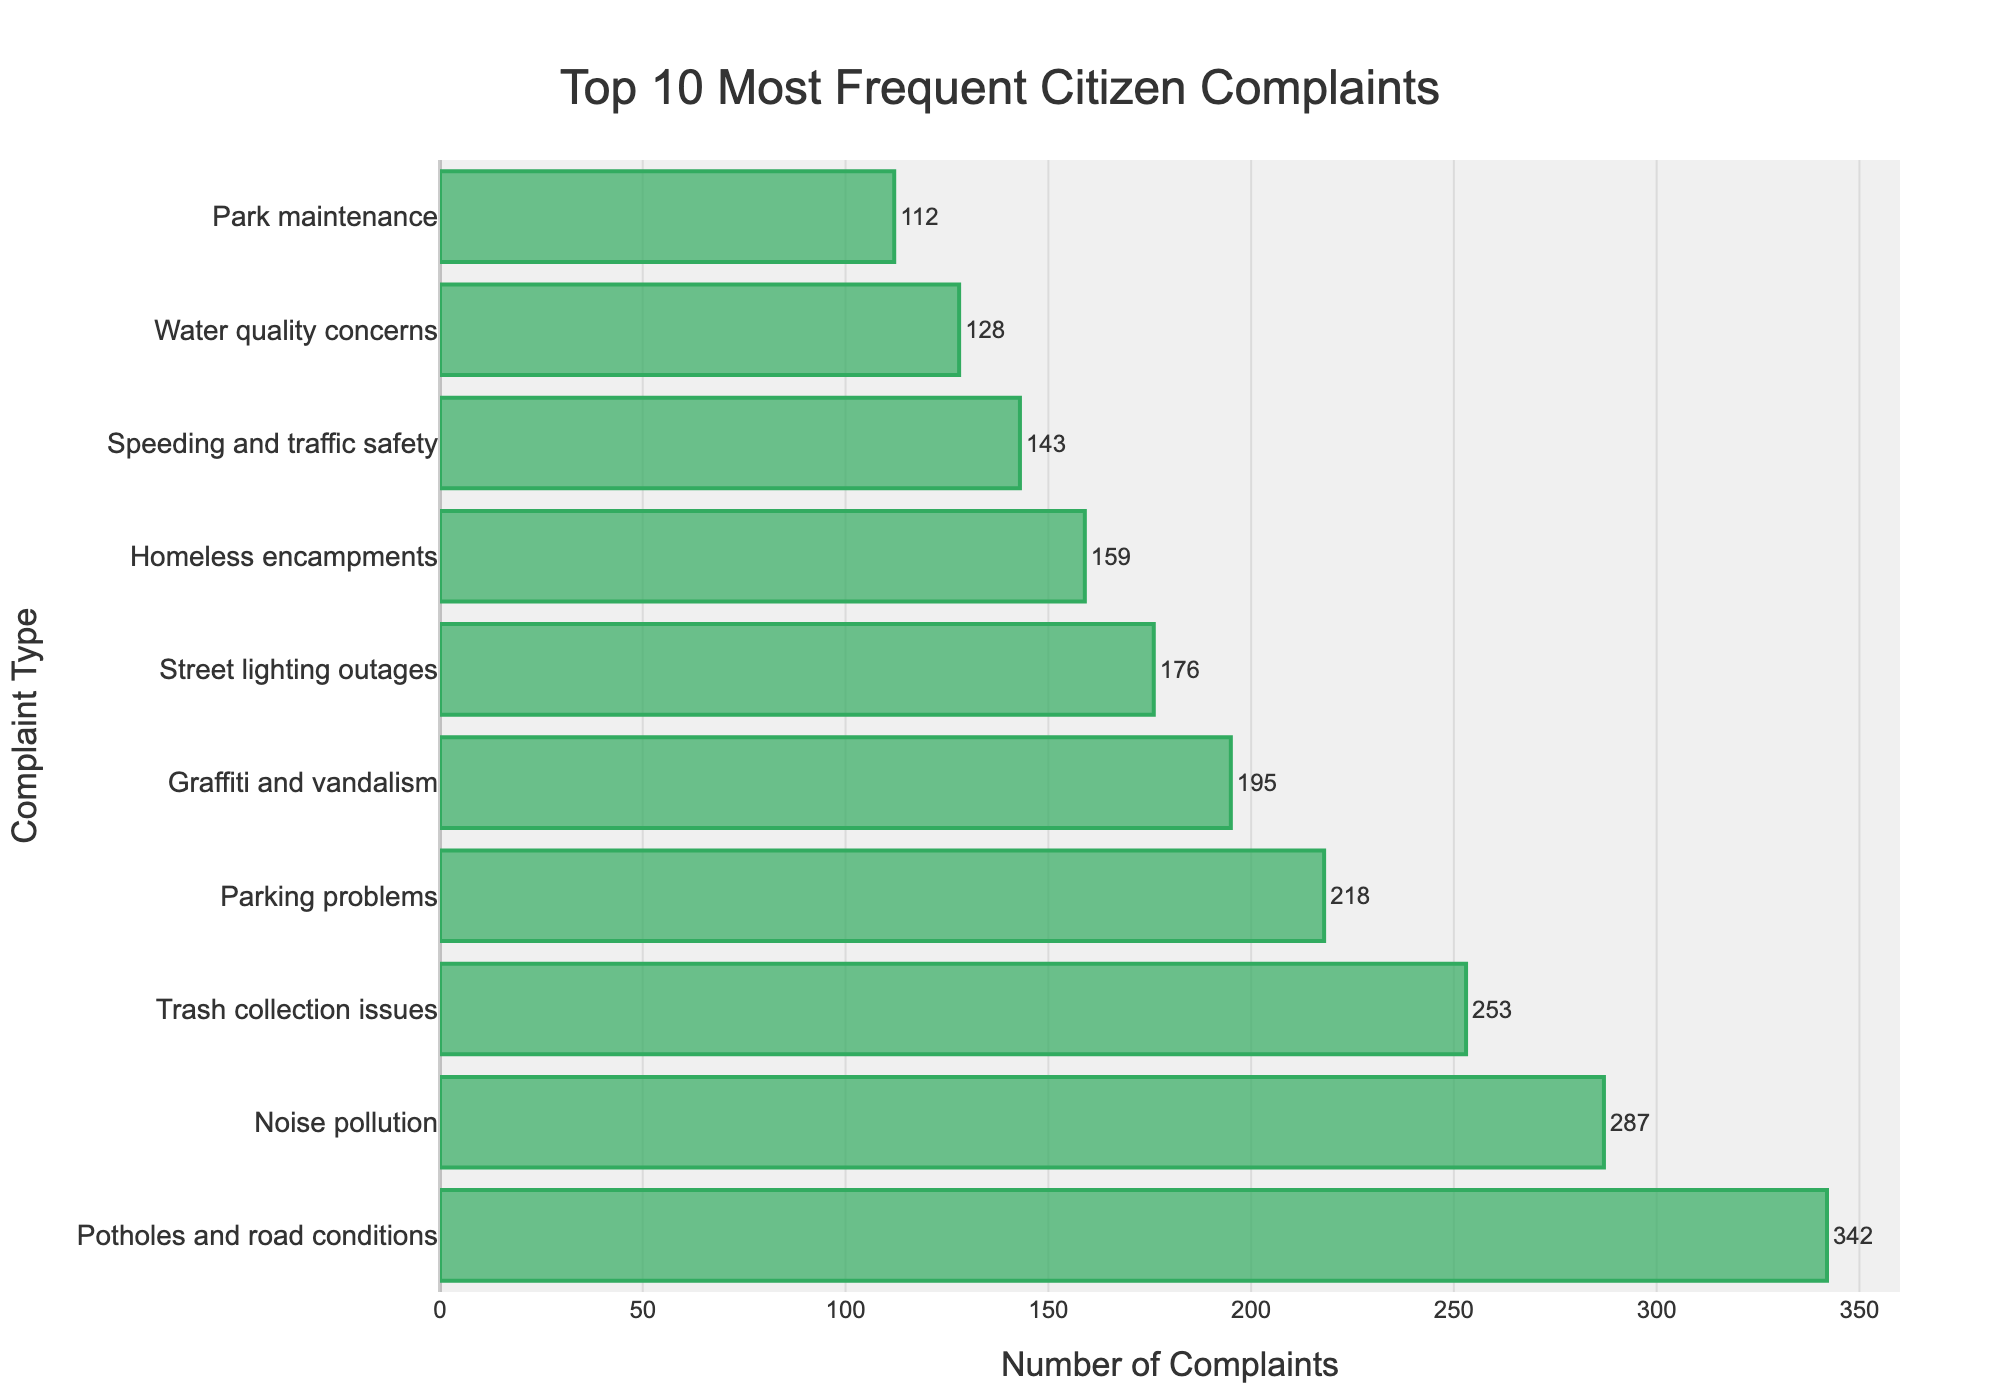Which complaint type has the highest frequency? The complaint type with the highest frequency is identified by the tallest bar. It is "Potholes and road conditions" with a frequency of 342.
Answer: Potholes and road conditions What is the combined frequency of the top three complaint types? The frequencies of the top three complaints ("Potholes and road conditions," "Noise pollution," and "Trash collection issues") are 342, 287, and 253, respectively. Summing these up, 342 + 287 + 253 = 882.
Answer: 882 Which complaint type has a higher frequency: "Graffiti and vandalism" or "Homeless encampments"? Check the lengths of the bars for "Graffiti and vandalism" and "Homeless encampments." "Graffiti and vandalism" has a frequency of 195, while "Homeless encampments" has a frequency of 159. Therefore, "Graffiti and vandalism" has a higher frequency.
Answer: Graffiti and vandalism How many more complaints are there about "Potholes and road conditions" than "Speeding and traffic safety"? Identify the frequencies: "Potholes and road conditions" is 342, and "Speeding and traffic safety" is 143. Calculate the difference: 342 - 143 = 199.
Answer: 199 What is the total number of complaints for all top 10 complaint types? Sum the frequencies of all top 10 complaint types: 342 (Potholes and road conditions) + 287 (Noise pollution) + 253 (Trash collection issues) + 218 (Parking problems) + 195 (Graffiti and vandalism) + 176 (Street lighting outages) + 159 (Homeless encampments) + 143 (Speeding and traffic safety) + 128 (Water quality concerns) + 112 (Park maintenance). The total is 2013.
Answer: 2013 What are the complaint types ranked 4th and 5th in terms of frequency? According to the bar heights, the 4th and 5th complaints in frequency are "Parking problems" (218 complaints) and "Graffiti and vandalism" (195 complaints).
Answer: Parking problems and Graffiti and vandalism Which complaint type has the lowest frequency among the top 10? The shortest bar indicates the lowest frequency among the top 10 complaint types, which is "Park maintenance" with 112 complaints.
Answer: Park maintenance Are there more complaints about "Trash collection issues" or "Street lighting outages"? Compare the frequencies: "Trash collection issues" has 253 complaints and "Street lighting outages" has 176 complaints. Therefore, "Trash collection issues" has more complaints.
Answer: Trash collection issues What is the average number of complaints for the top 5 complaint types? The top 5 complaint types are: 342 (Potholes and road conditions), 287 (Noise pollution), 253 (Trash collection issues), 218 (Parking problems), and 195 (Graffiti and vandalism). Sum these and divide by 5 to find the average: (342 + 287 + 253 + 218 + 195) / 5 = 1295 / 5 = 259.
Answer: 259 By how much do complaints about "Noise pollution" exceed those about "Street lighting outages"? Identify the frequencies: "Noise pollution" is 287, and "Street lighting outages" is 176. Subtracting the smaller from the larger gives: 287 - 176 = 111.
Answer: 111 